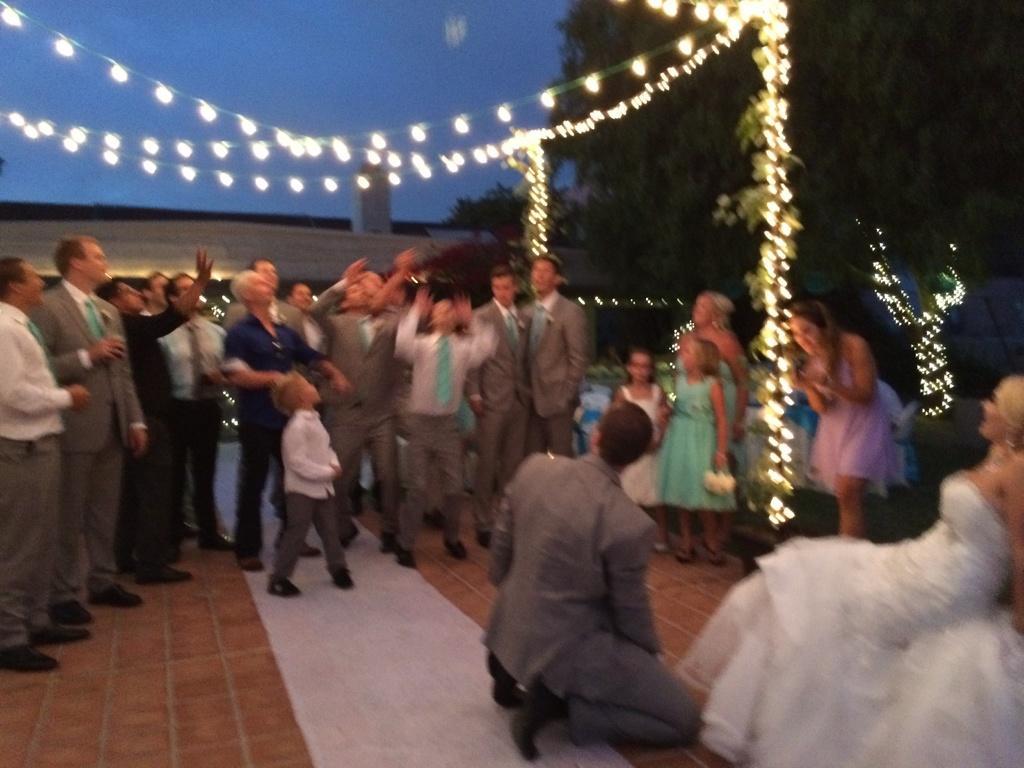Describe this image in one or two sentences. In the given image i can see a people,light strings,trees,floor mat and in the background i can see the sky. 